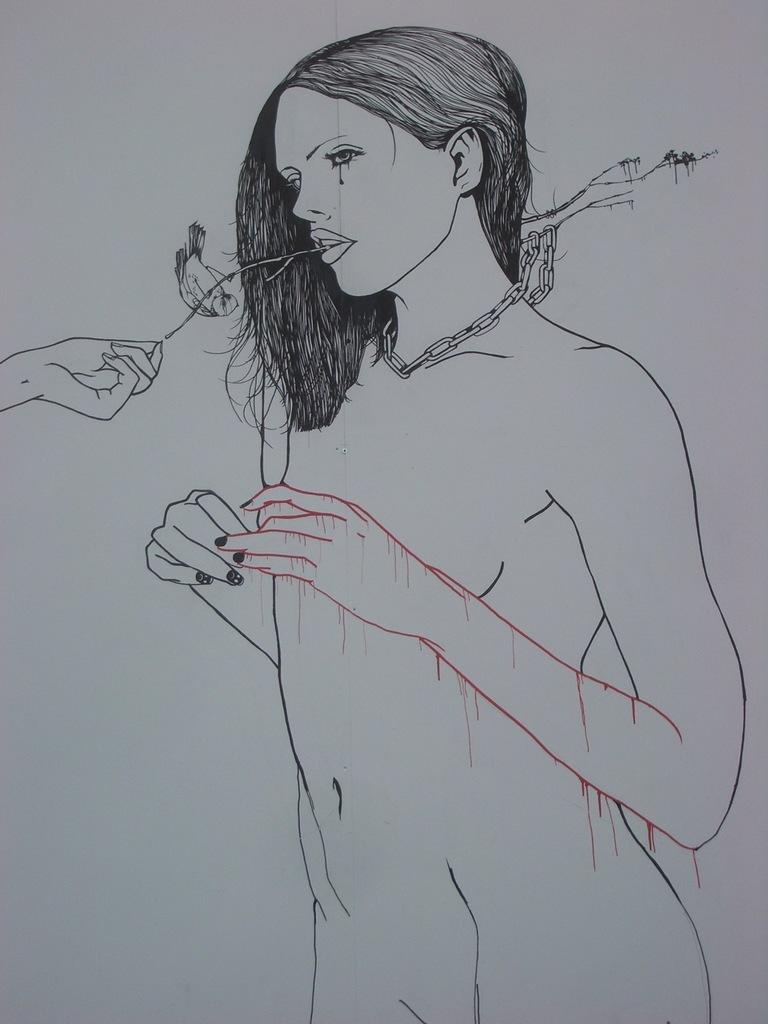What type of artwork is depicted in the image? There is a pencil sketch in the image. What subject is the sketch focused on? The sketch is of a woman. What color is the paper on which the sketch is drawn? The paper is white. How many quinces are included in the pencil sketch? There are no quinces present in the pencil sketch; it is a sketch of a woman. What type of behavior is exhibited by the woman in the sketch? The image is a static pencil sketch, so it does not depict any behavior or actions. 